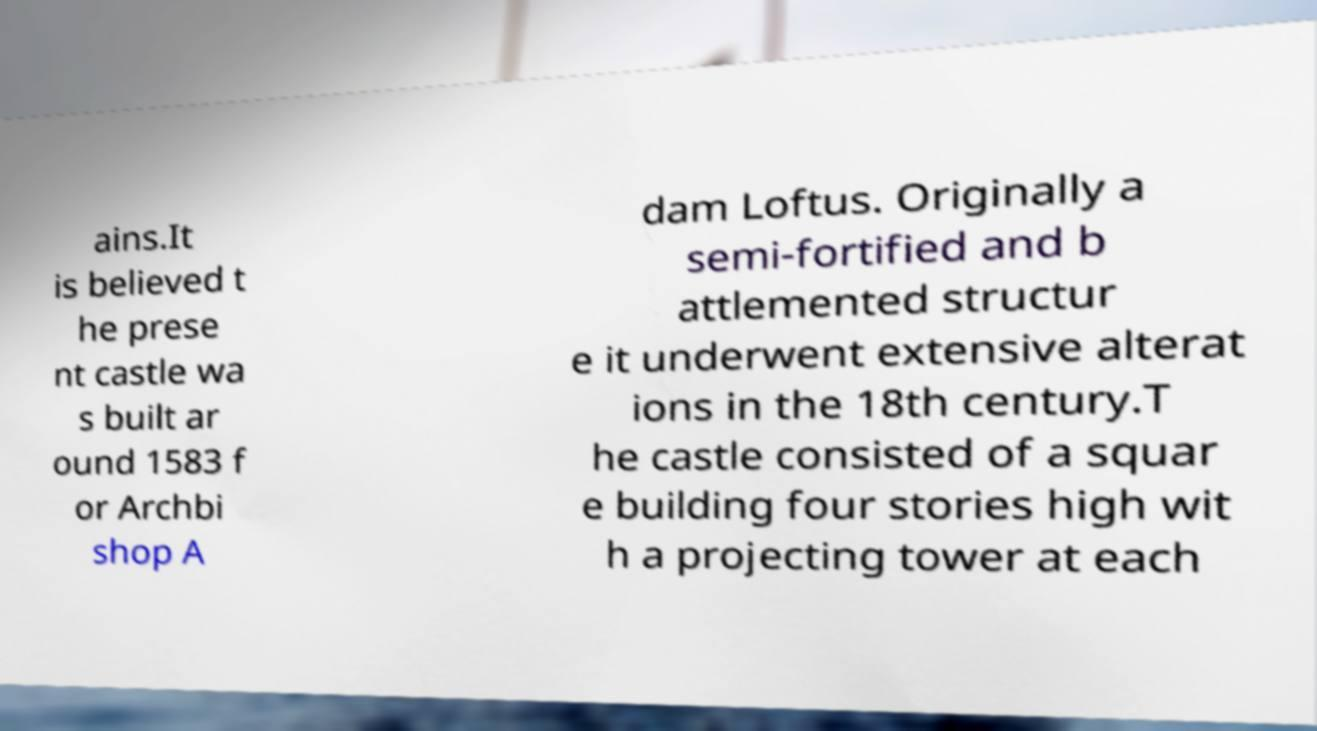Could you assist in decoding the text presented in this image and type it out clearly? ains.It is believed t he prese nt castle wa s built ar ound 1583 f or Archbi shop A dam Loftus. Originally a semi-fortified and b attlemented structur e it underwent extensive alterat ions in the 18th century.T he castle consisted of a squar e building four stories high wit h a projecting tower at each 